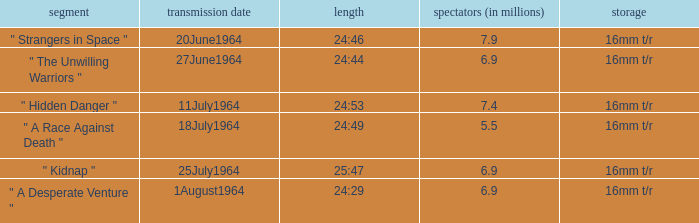How many viewers were there on 1august1964? 6.9. 